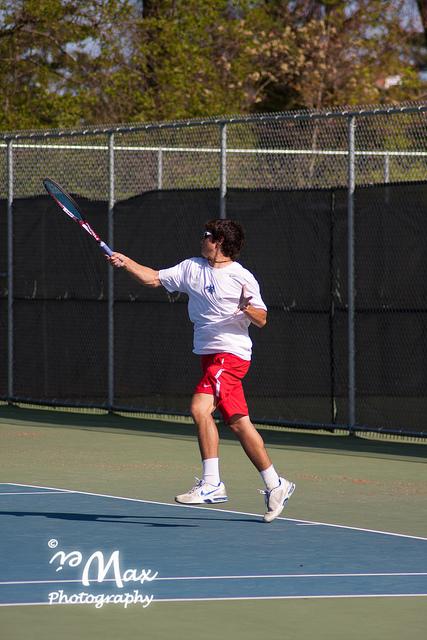What color is the fence?
Keep it brief. Silver. What part of this guy is touching the ground?
Short answer required. Foot. What color shorts is the man wearing?
Keep it brief. Red. Is this game in a stadium?
Write a very short answer. No. 